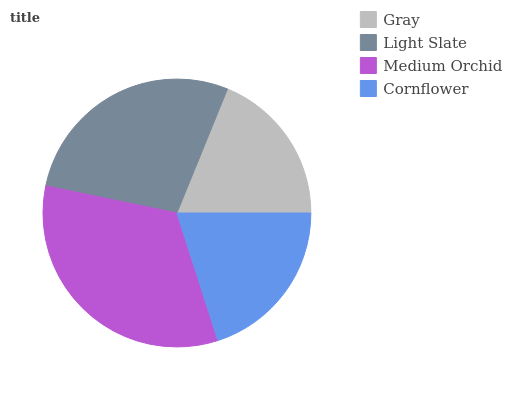Is Gray the minimum?
Answer yes or no. Yes. Is Medium Orchid the maximum?
Answer yes or no. Yes. Is Light Slate the minimum?
Answer yes or no. No. Is Light Slate the maximum?
Answer yes or no. No. Is Light Slate greater than Gray?
Answer yes or no. Yes. Is Gray less than Light Slate?
Answer yes or no. Yes. Is Gray greater than Light Slate?
Answer yes or no. No. Is Light Slate less than Gray?
Answer yes or no. No. Is Light Slate the high median?
Answer yes or no. Yes. Is Cornflower the low median?
Answer yes or no. Yes. Is Cornflower the high median?
Answer yes or no. No. Is Light Slate the low median?
Answer yes or no. No. 